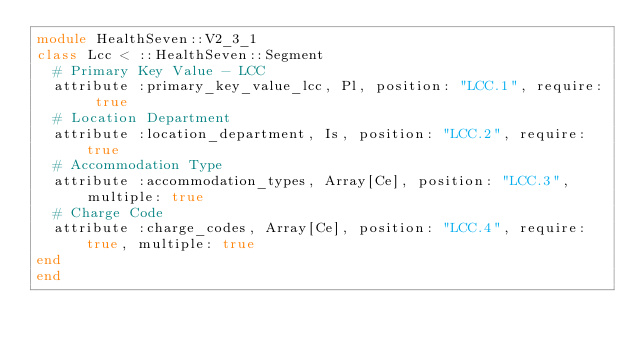Convert code to text. <code><loc_0><loc_0><loc_500><loc_500><_Ruby_>module HealthSeven::V2_3_1
class Lcc < ::HealthSeven::Segment
  # Primary Key Value - LCC
  attribute :primary_key_value_lcc, Pl, position: "LCC.1", require: true
  # Location Department
  attribute :location_department, Is, position: "LCC.2", require: true
  # Accommodation Type
  attribute :accommodation_types, Array[Ce], position: "LCC.3", multiple: true
  # Charge Code
  attribute :charge_codes, Array[Ce], position: "LCC.4", require: true, multiple: true
end
end</code> 